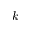Convert formula to latex. <formula><loc_0><loc_0><loc_500><loc_500>k</formula> 